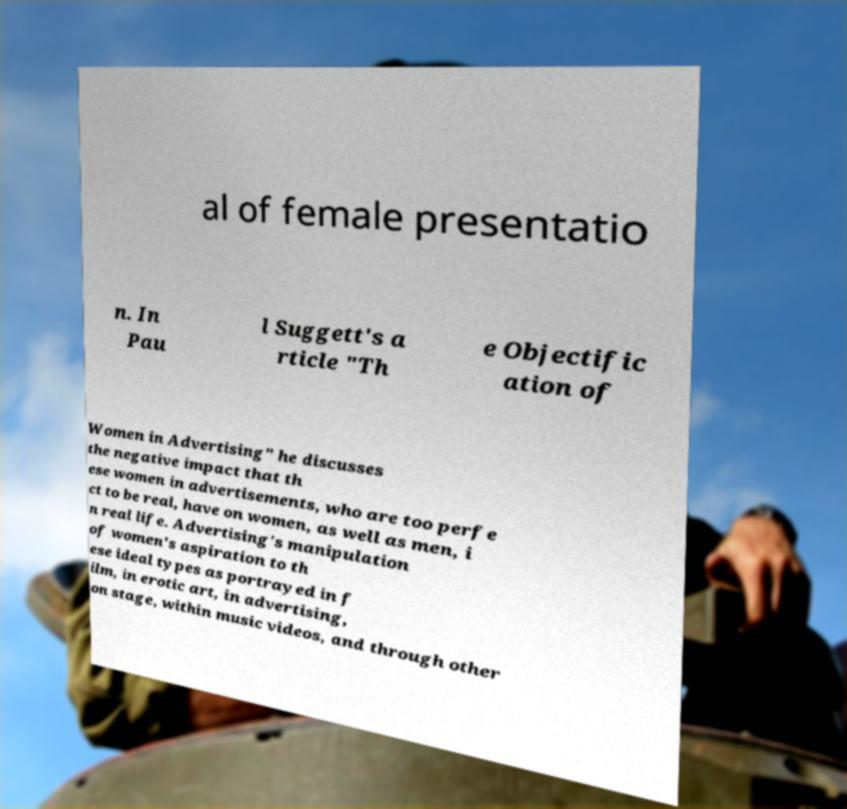There's text embedded in this image that I need extracted. Can you transcribe it verbatim? al of female presentatio n. In Pau l Suggett's a rticle "Th e Objectific ation of Women in Advertising" he discusses the negative impact that th ese women in advertisements, who are too perfe ct to be real, have on women, as well as men, i n real life. Advertising's manipulation of women's aspiration to th ese ideal types as portrayed in f ilm, in erotic art, in advertising, on stage, within music videos, and through other 